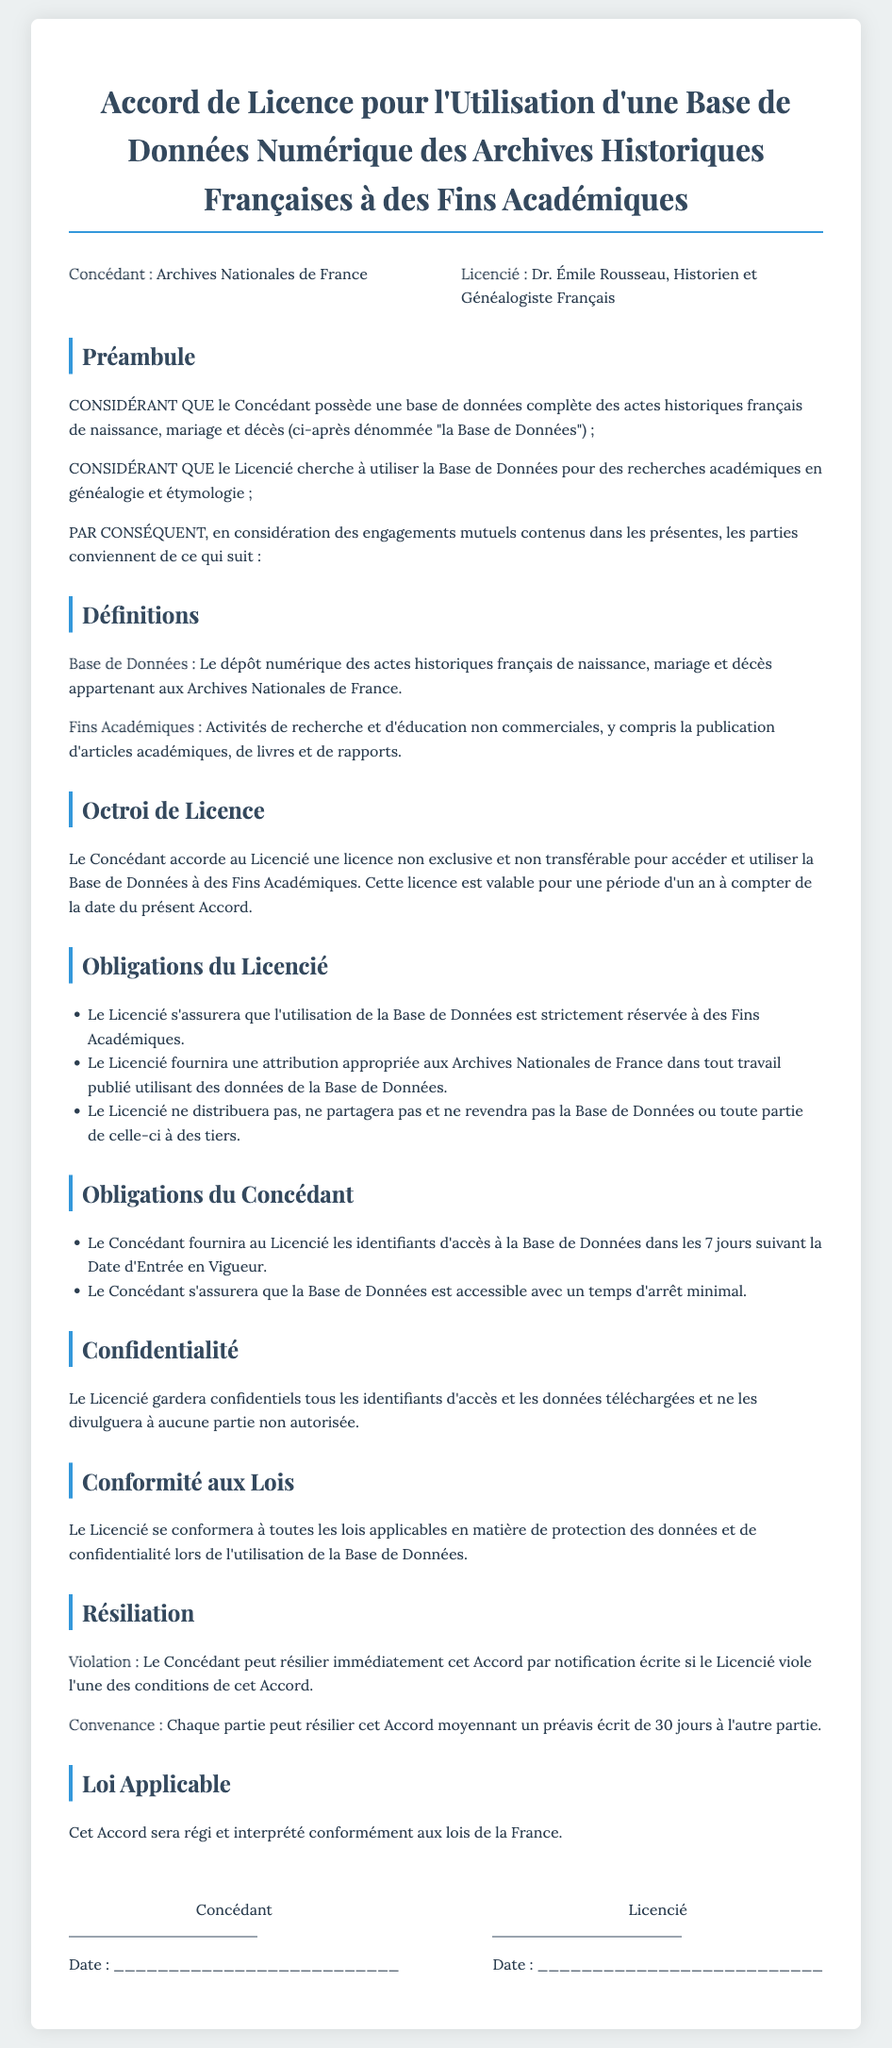What is the title of the document? The title of the document is specified in the header section and indicates the purpose of the agreement, which is a licensing agreement for using a digital database.
Answer: Accord de Licence pour l'Utilisation d'une Base de Données Numérique des Archives Historiques Françaises à des Fins Académiques Who is the Licencié? The Licencié is a party involved in the contract who wants to use the database for academic purposes, and their name is provided in the document.
Answer: Dr. Émile Rousseau What period is the license valid for? The document specifies the duration of the license granted to the Licencié, indicating its validity period.
Answer: un an What does the term "Fins Académiques" refer to? This term is defined in the document and describes the intended use of the database by the Licencié.
Answer: Activités de recherche et d'éducation non commerciales What must the Licencié provide in published work? The document states the obligation of the Licencié regarding attribution in works that utilize the database.
Answer: une attribution appropriée aux Archives Nationales de France What is the consequence of a violation of the agreement? The document outlines the actions that the Concédant can take in response to a breach of the contract terms by the Licencié.
Answer: résilier immédiatement cet Accord What is the notice period for termination by either party? The agreement states how much advance notice is required if either party wishes to terminate the contract.
Answer: 30 jours What is the governing law for this agreement? The section regarding the applicable law in the document specifies which laws will govern the agreement.
Answer: lois de la France 